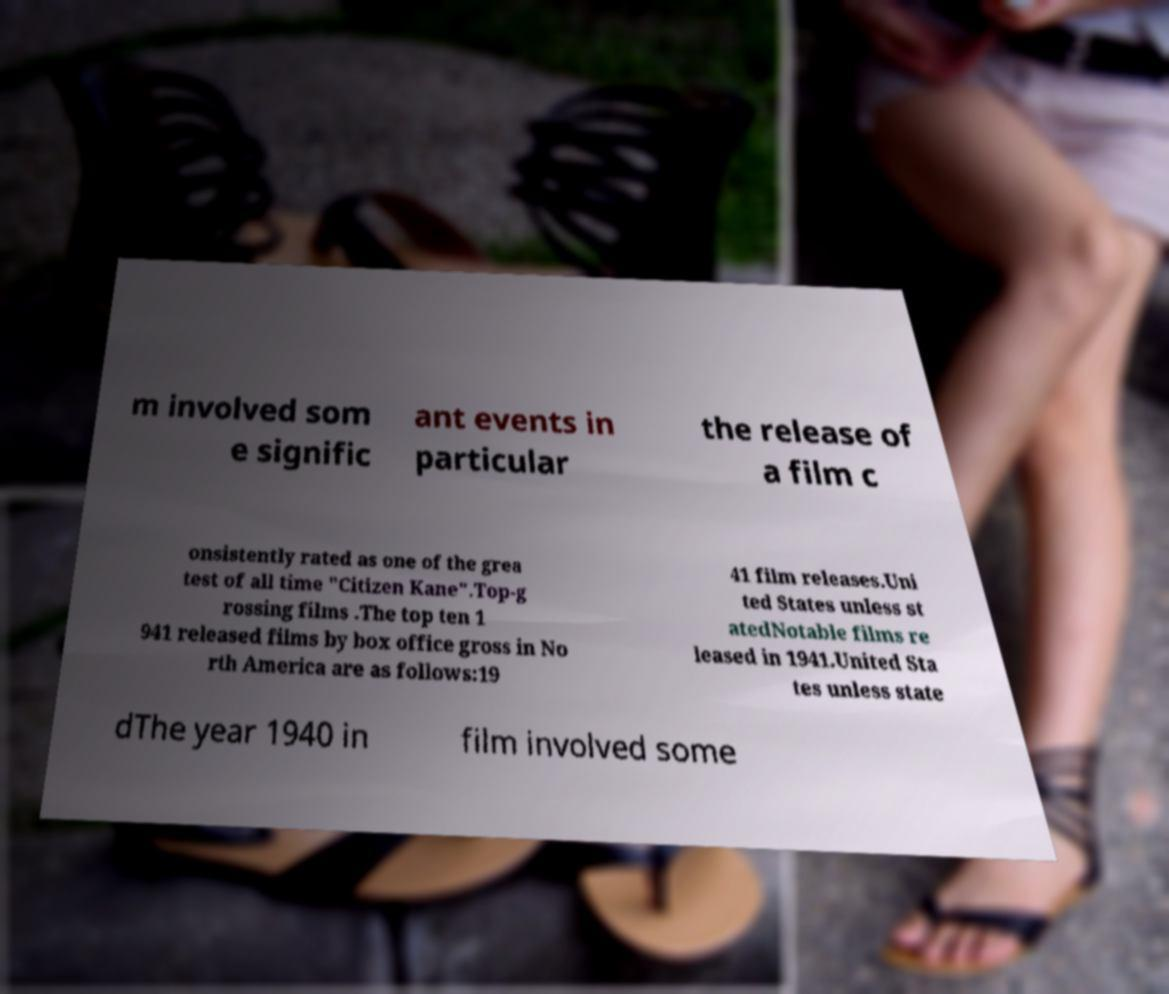Can you read and provide the text displayed in the image?This photo seems to have some interesting text. Can you extract and type it out for me? m involved som e signific ant events in particular the release of a film c onsistently rated as one of the grea test of all time "Citizen Kane".Top-g rossing films .The top ten 1 941 released films by box office gross in No rth America are as follows:19 41 film releases.Uni ted States unless st atedNotable films re leased in 1941.United Sta tes unless state dThe year 1940 in film involved some 